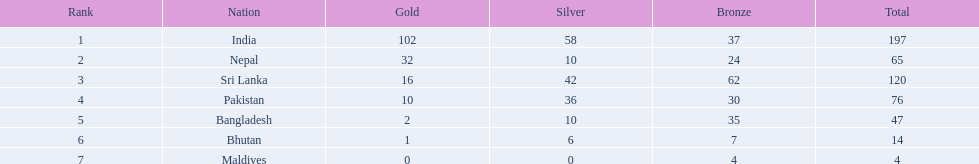What countries attended the 1999 south asian games? India, Nepal, Sri Lanka, Pakistan, Bangladesh, Bhutan, Maldives. Which of these countries had 32 gold medals? Nepal. 